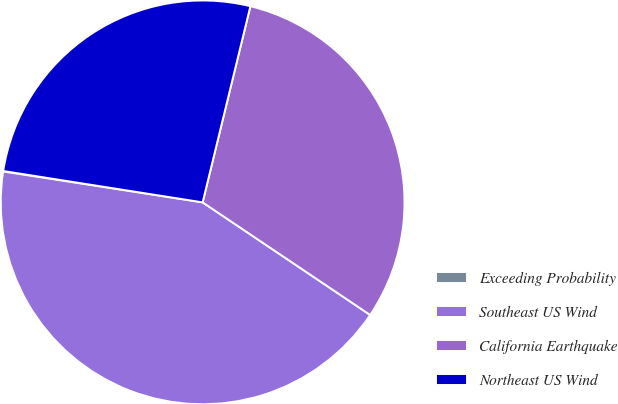Convert chart. <chart><loc_0><loc_0><loc_500><loc_500><pie_chart><fcel>Exceeding Probability<fcel>Southeast US Wind<fcel>California Earthquake<fcel>Northeast US Wind<nl><fcel>0.04%<fcel>43.03%<fcel>30.62%<fcel>26.32%<nl></chart> 